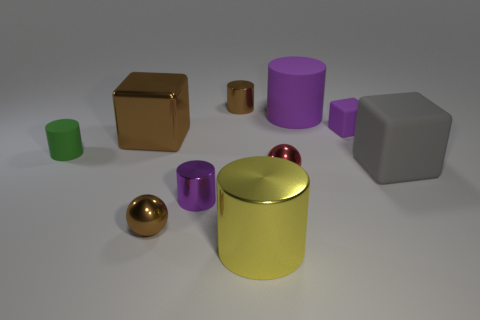Subtract 1 cylinders. How many cylinders are left? 4 Subtract all yellow cylinders. How many cylinders are left? 4 Subtract all brown cylinders. How many cylinders are left? 4 Subtract all blue cylinders. Subtract all gray blocks. How many cylinders are left? 5 Subtract all spheres. How many objects are left? 8 Add 7 tiny blue things. How many tiny blue things exist? 7 Subtract 0 red cubes. How many objects are left? 10 Subtract all small red metal spheres. Subtract all brown balls. How many objects are left? 8 Add 7 large metal objects. How many large metal objects are left? 9 